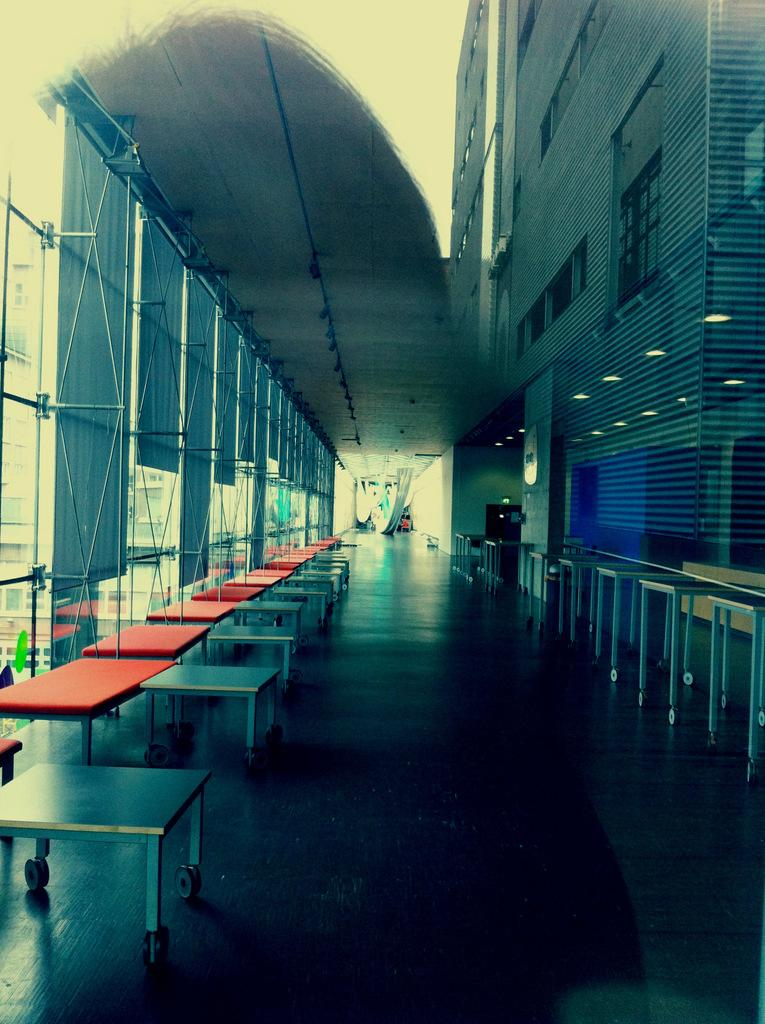What type of furniture is present in the image? There are stools with wheels and tables with wheels in the image. What material is used for the walls in the image? The walls in the image are made of glass. What can be seen on the right side of the image? There is a building with windows on the right side of the image. How many trucks are visible in the image? There are no trucks present in the image. What type of question is being asked in the image? There is no question visible in the image. 